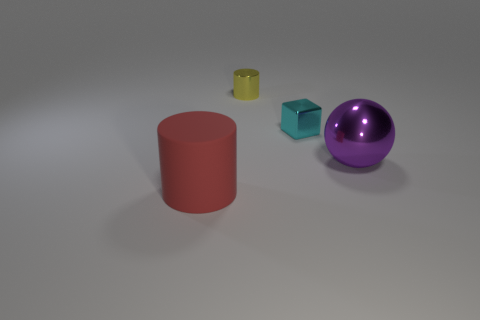Add 4 purple metallic things. How many objects exist? 8 Subtract all cubes. How many objects are left? 3 Subtract 0 blue cubes. How many objects are left? 4 Subtract 1 spheres. How many spheres are left? 0 Subtract all brown cylinders. Subtract all blue cubes. How many cylinders are left? 2 Subtract all purple blocks. How many yellow spheres are left? 0 Subtract all big red rubber cylinders. Subtract all large yellow cubes. How many objects are left? 3 Add 2 tiny yellow metallic things. How many tiny yellow metallic things are left? 3 Add 4 large yellow shiny blocks. How many large yellow shiny blocks exist? 4 